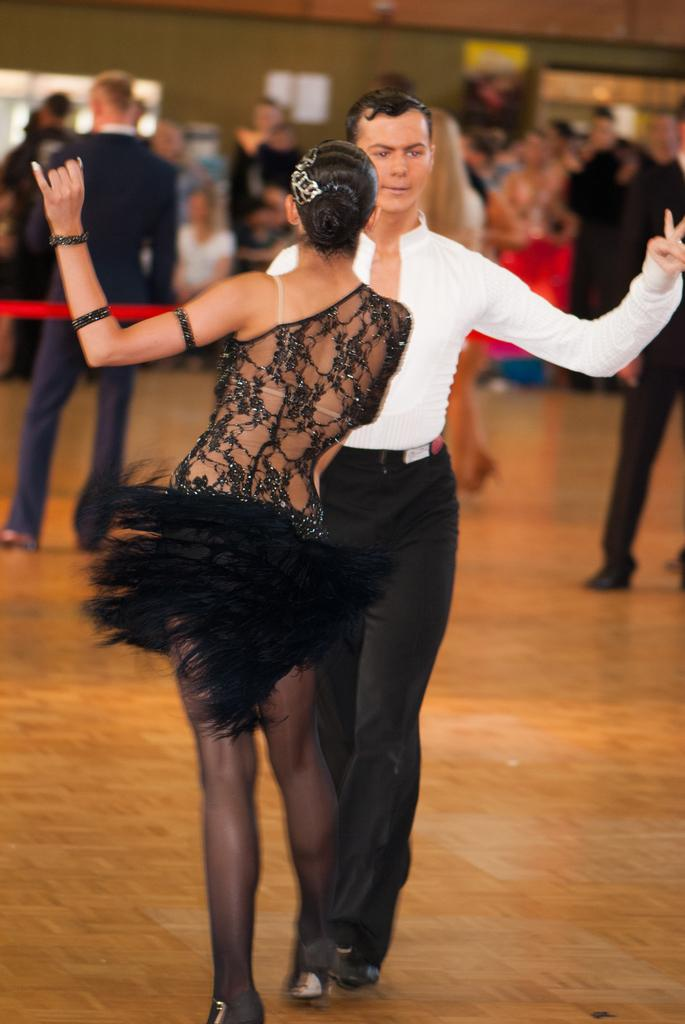How many people are present in the image? There are three people standing in the image. What type of flooring can be seen beneath the people? The people are standing on a wooden floor. What is visible in the background of the image? There is a wall visible in the background of the image. How would you describe the background of the image? The background of the image is blurred. What type of comb is being used to style the hair of the person in the image? There is no comb visible in the image, and no one is shown styling their hair. 